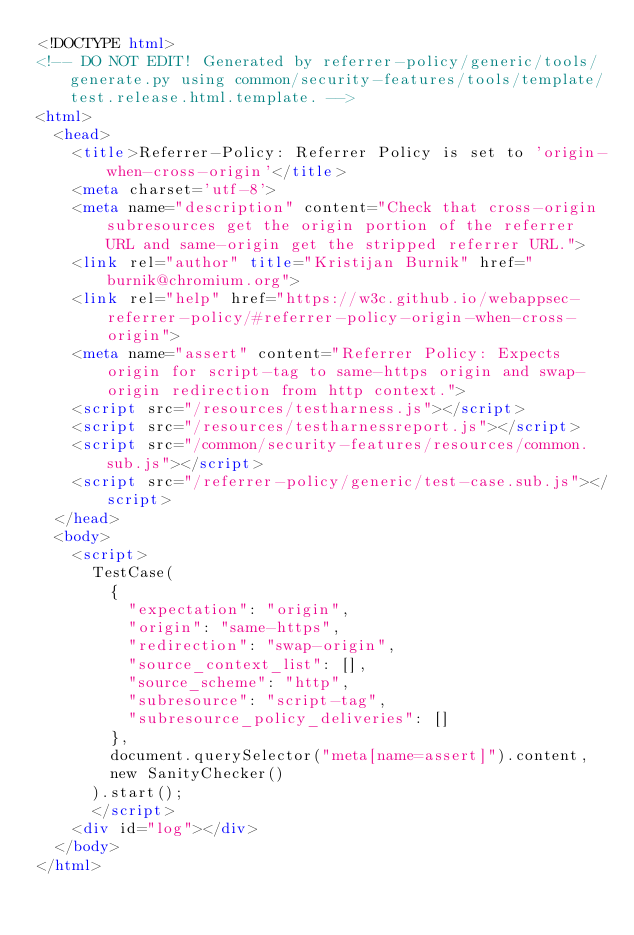Convert code to text. <code><loc_0><loc_0><loc_500><loc_500><_HTML_><!DOCTYPE html>
<!-- DO NOT EDIT! Generated by referrer-policy/generic/tools/generate.py using common/security-features/tools/template/test.release.html.template. -->
<html>
  <head>
    <title>Referrer-Policy: Referrer Policy is set to 'origin-when-cross-origin'</title>
    <meta charset='utf-8'>
    <meta name="description" content="Check that cross-origin subresources get the origin portion of the referrer URL and same-origin get the stripped referrer URL.">
    <link rel="author" title="Kristijan Burnik" href="burnik@chromium.org">
    <link rel="help" href="https://w3c.github.io/webappsec-referrer-policy/#referrer-policy-origin-when-cross-origin">
    <meta name="assert" content="Referrer Policy: Expects origin for script-tag to same-https origin and swap-origin redirection from http context.">
    <script src="/resources/testharness.js"></script>
    <script src="/resources/testharnessreport.js"></script>
    <script src="/common/security-features/resources/common.sub.js"></script>
    <script src="/referrer-policy/generic/test-case.sub.js"></script>
  </head>
  <body>
    <script>
      TestCase(
        {
          "expectation": "origin",
          "origin": "same-https",
          "redirection": "swap-origin",
          "source_context_list": [],
          "source_scheme": "http",
          "subresource": "script-tag",
          "subresource_policy_deliveries": []
        },
        document.querySelector("meta[name=assert]").content,
        new SanityChecker()
      ).start();
      </script>
    <div id="log"></div>
  </body>
</html>
</code> 